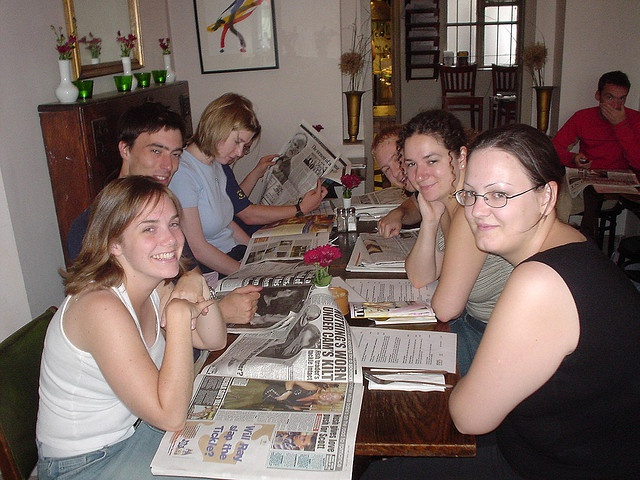Describe the objects in this image and their specific colors. I can see dining table in gray, darkgray, and black tones, people in gray, black, and pink tones, people in gray, tan, lightgray, and darkgray tones, people in gray, tan, and darkgray tones, and people in gray and black tones in this image. 